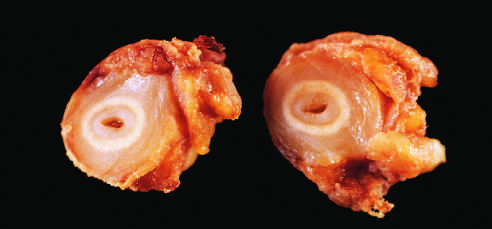do the histone subunits shown in the figure demonstrate marked intimal thickening and luminal narrowing?
Answer the question using a single word or phrase. No 